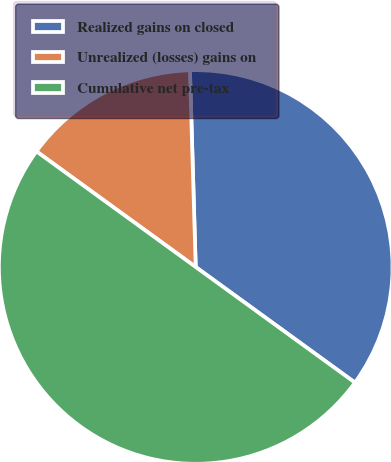<chart> <loc_0><loc_0><loc_500><loc_500><pie_chart><fcel>Realized gains on closed<fcel>Unrealized (losses) gains on<fcel>Cumulative net pre-tax<nl><fcel>35.46%<fcel>14.54%<fcel>50.0%<nl></chart> 